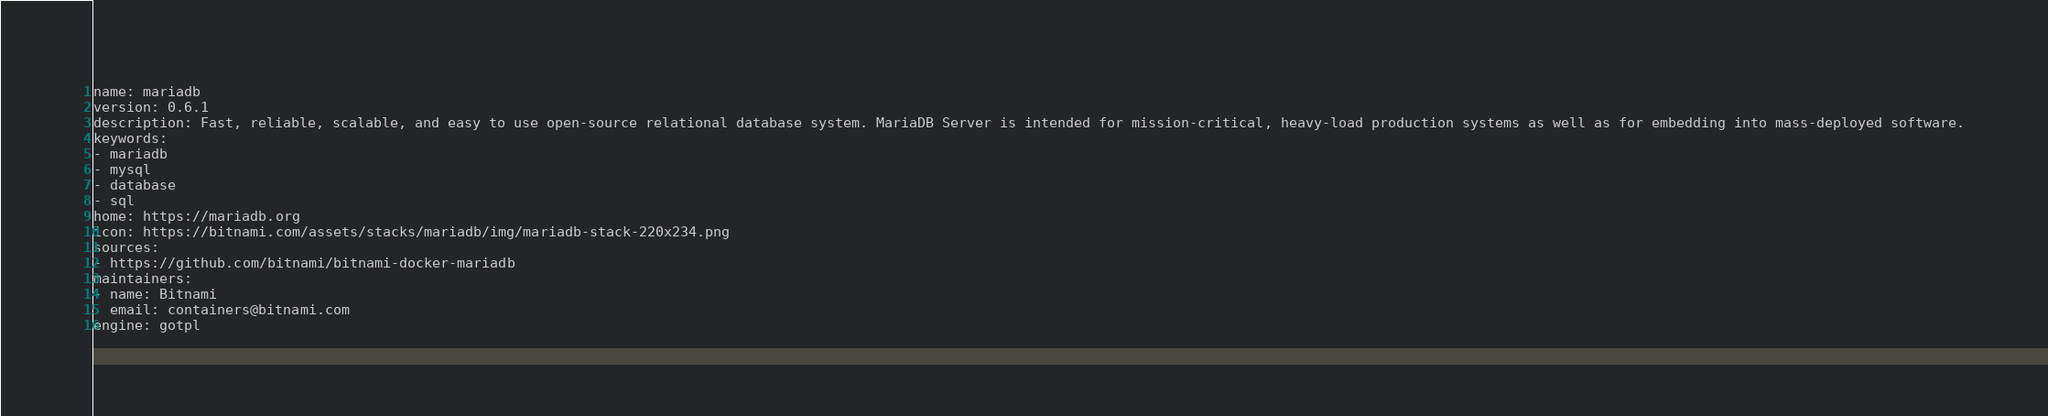<code> <loc_0><loc_0><loc_500><loc_500><_YAML_>name: mariadb
version: 0.6.1
description: Fast, reliable, scalable, and easy to use open-source relational database system. MariaDB Server is intended for mission-critical, heavy-load production systems as well as for embedding into mass-deployed software.
keywords:
- mariadb
- mysql
- database
- sql
home: https://mariadb.org
icon: https://bitnami.com/assets/stacks/mariadb/img/mariadb-stack-220x234.png
sources:
- https://github.com/bitnami/bitnami-docker-mariadb
maintainers:
- name: Bitnami
  email: containers@bitnami.com
engine: gotpl
</code> 